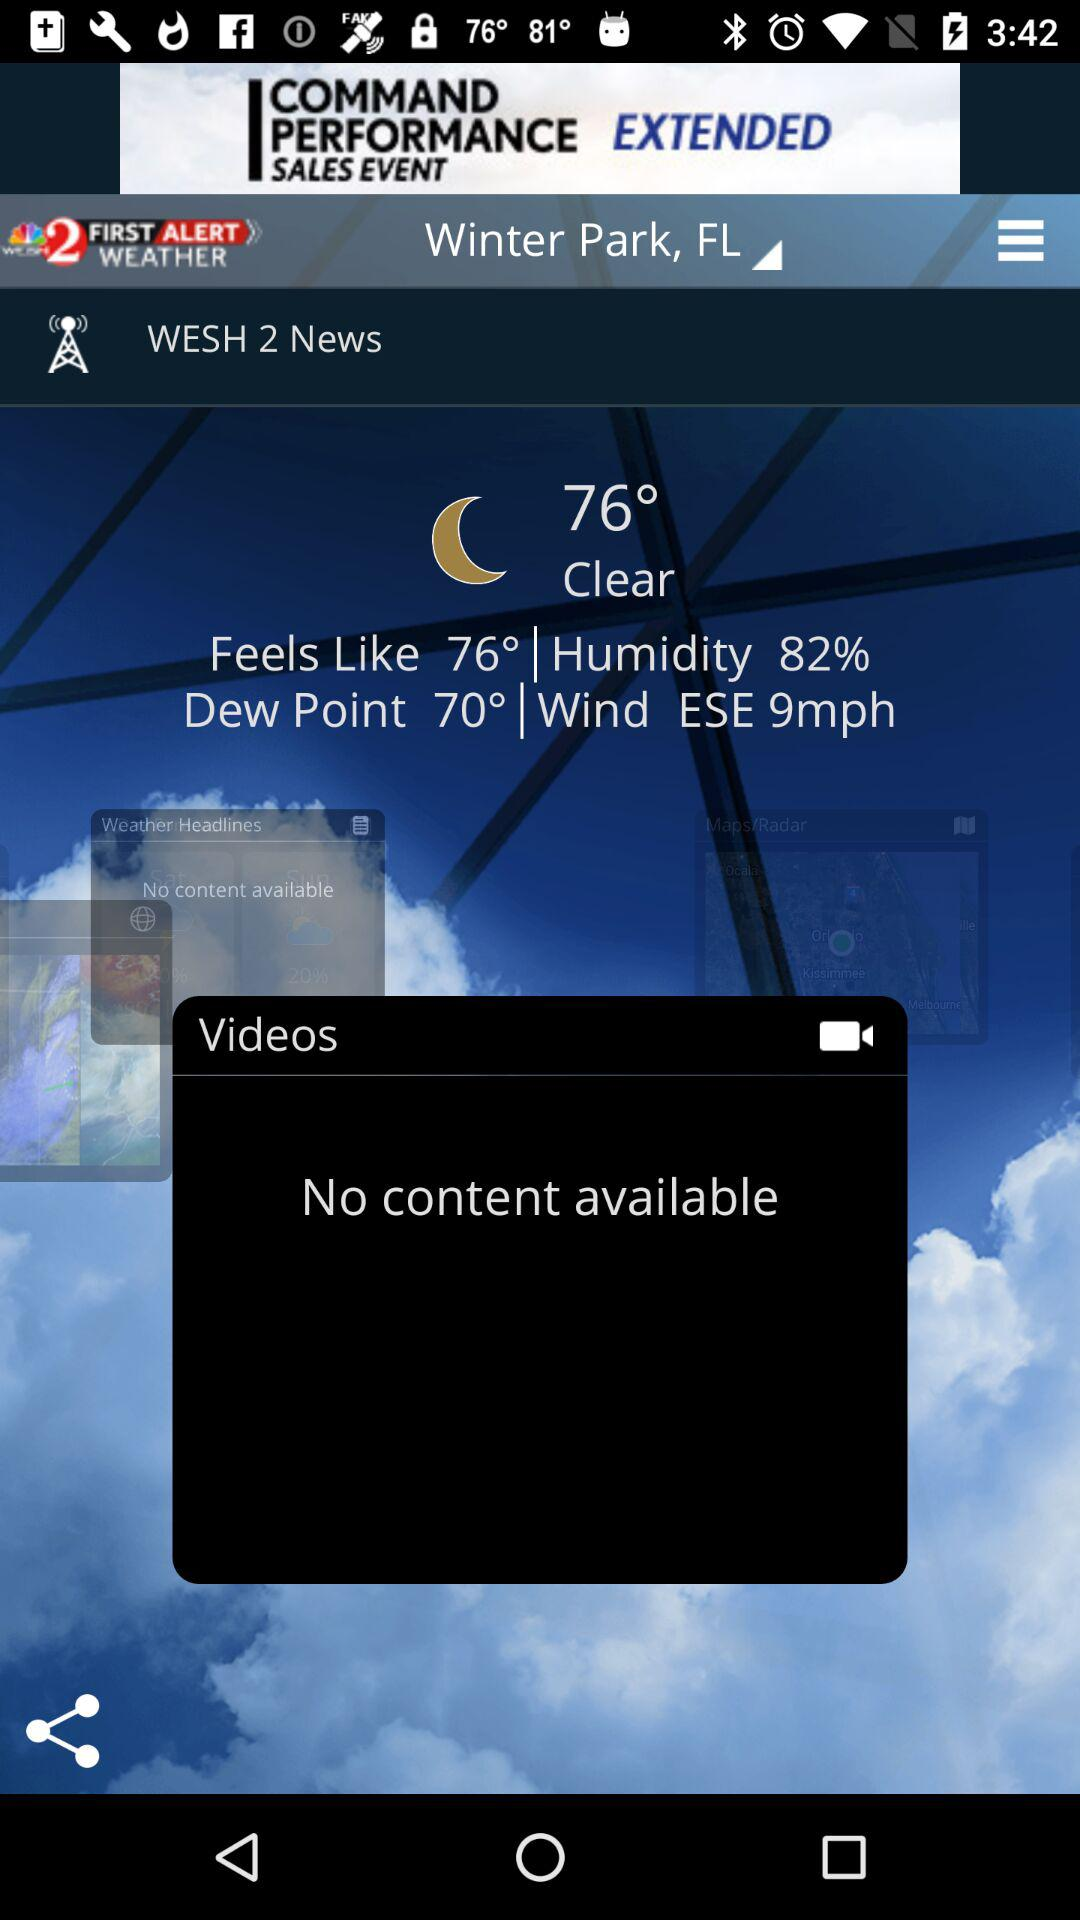How many weather elements are shown on the screen?
Answer the question using a single word or phrase. 4 